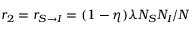<formula> <loc_0><loc_0><loc_500><loc_500>r _ { 2 } = r _ { S \rightarrow I } = ( 1 - \eta ) \lambda N _ { S } N _ { I } / N</formula> 